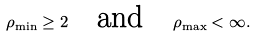<formula> <loc_0><loc_0><loc_500><loc_500>\rho _ { \min } \geq 2 \quad \text {and} \quad \rho _ { \max } < \infty .</formula> 